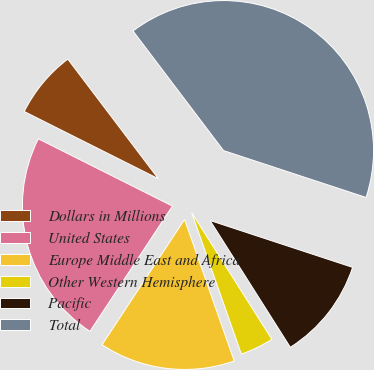Convert chart to OTSL. <chart><loc_0><loc_0><loc_500><loc_500><pie_chart><fcel>Dollars in Millions<fcel>United States<fcel>Europe Middle East and Africa<fcel>Other Western Hemisphere<fcel>Pacific<fcel>Total<nl><fcel>7.29%<fcel>23.13%<fcel>14.64%<fcel>3.61%<fcel>10.96%<fcel>40.37%<nl></chart> 